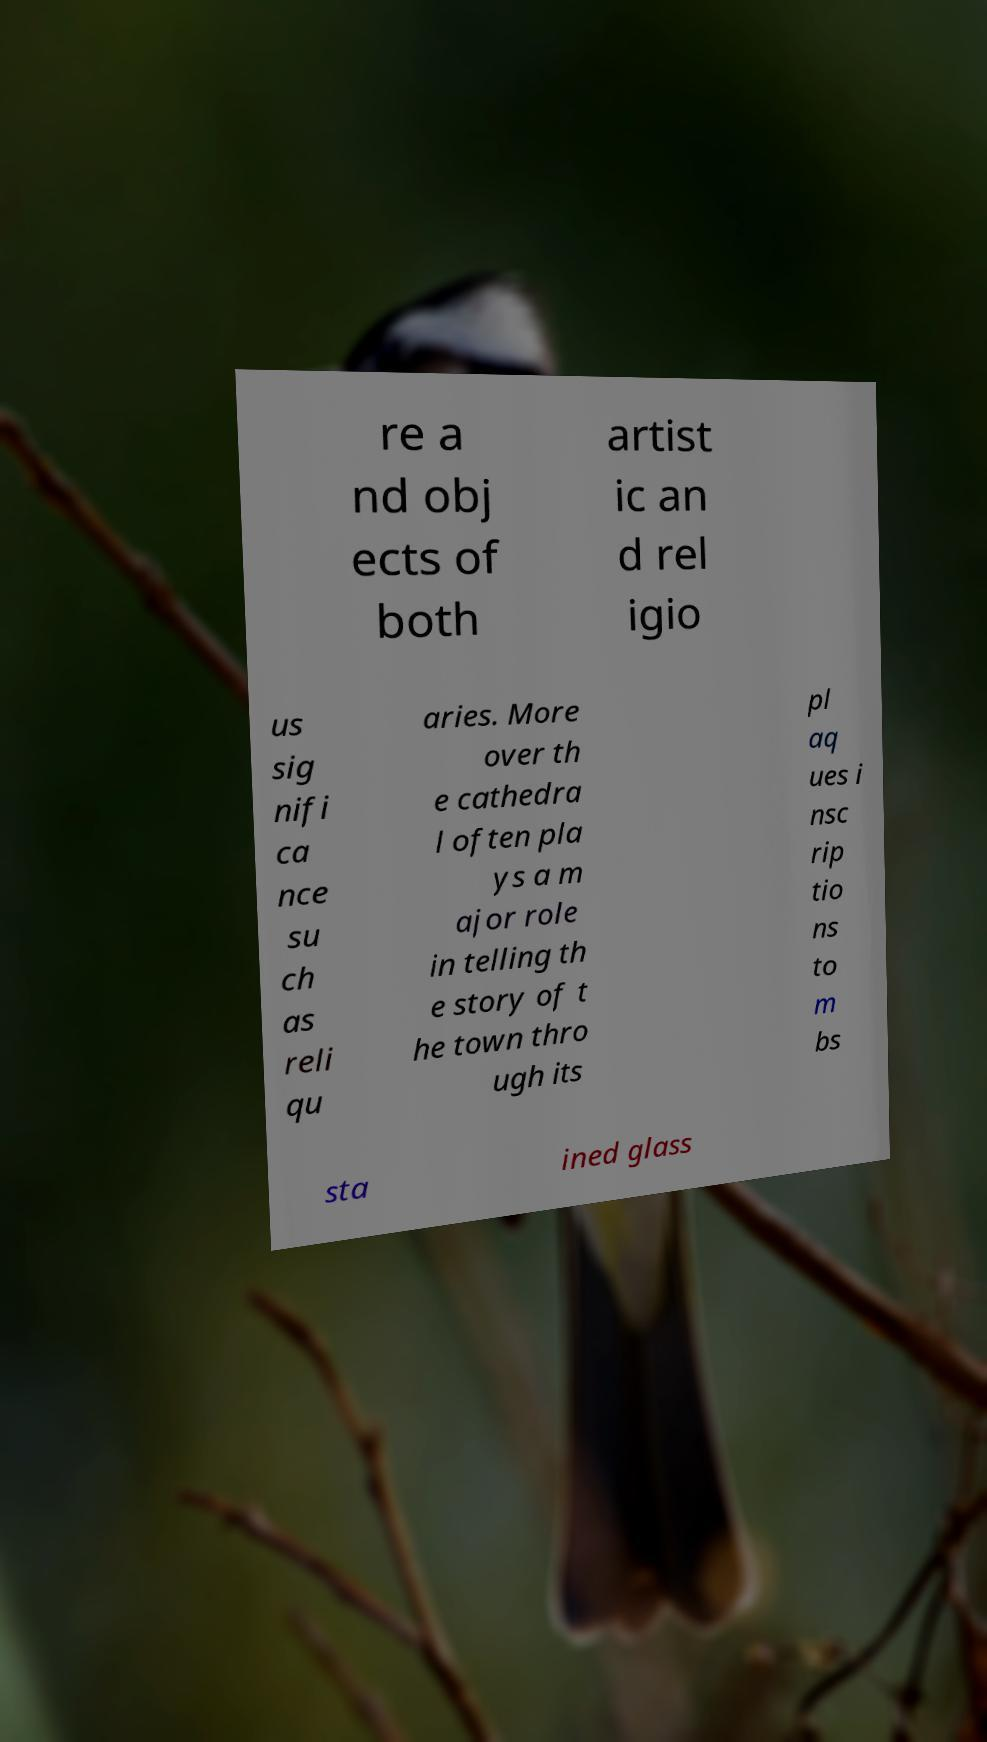Can you read and provide the text displayed in the image?This photo seems to have some interesting text. Can you extract and type it out for me? re a nd obj ects of both artist ic an d rel igio us sig nifi ca nce su ch as reli qu aries. More over th e cathedra l often pla ys a m ajor role in telling th e story of t he town thro ugh its pl aq ues i nsc rip tio ns to m bs sta ined glass 